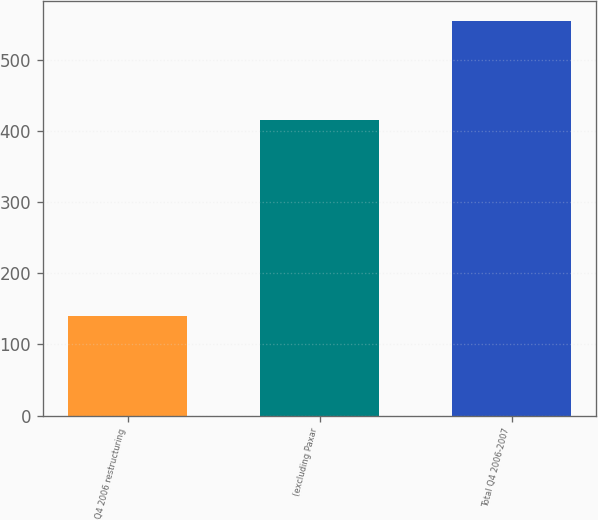<chart> <loc_0><loc_0><loc_500><loc_500><bar_chart><fcel>Q4 2006 restructuring<fcel>(excluding Paxar<fcel>Total Q4 2006-2007<nl><fcel>140<fcel>415<fcel>555<nl></chart> 